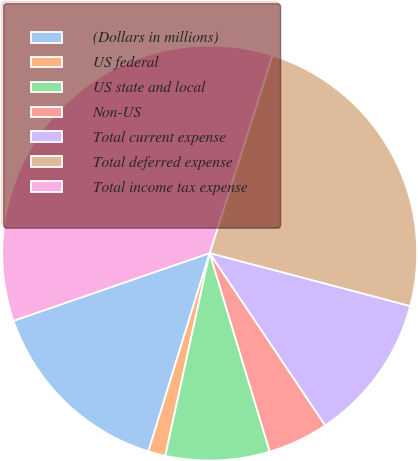<chart> <loc_0><loc_0><loc_500><loc_500><pie_chart><fcel>(Dollars in millions)<fcel>US federal<fcel>US state and local<fcel>Non-US<fcel>Total current expense<fcel>Total deferred expense<fcel>Total income tax expense<nl><fcel>14.94%<fcel>1.34%<fcel>8.11%<fcel>4.72%<fcel>11.49%<fcel>24.21%<fcel>35.19%<nl></chart> 